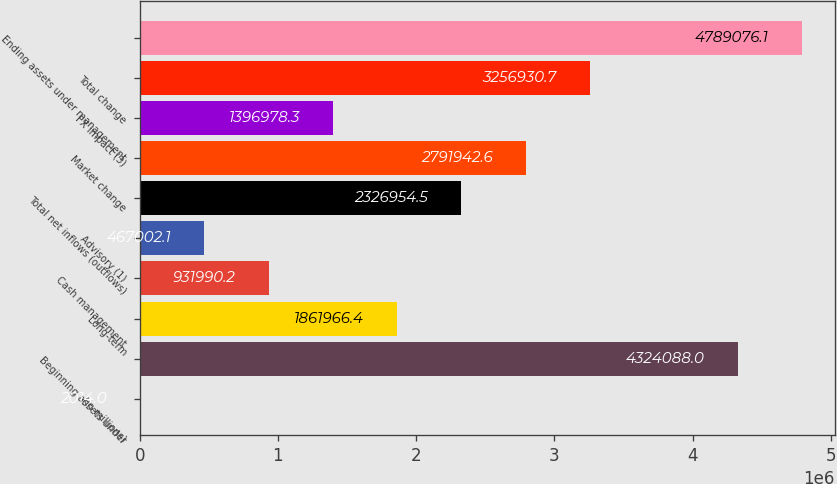Convert chart. <chart><loc_0><loc_0><loc_500><loc_500><bar_chart><fcel>(in millions)<fcel>Beginning assets under<fcel>Long-term<fcel>Cash management<fcel>Advisory (1)<fcel>Total net inflows (outflows)<fcel>Market change<fcel>FX impact (3)<fcel>Total change<fcel>Ending assets under management<nl><fcel>2014<fcel>4.32409e+06<fcel>1.86197e+06<fcel>931990<fcel>467002<fcel>2.32695e+06<fcel>2.79194e+06<fcel>1.39698e+06<fcel>3.25693e+06<fcel>4.78908e+06<nl></chart> 